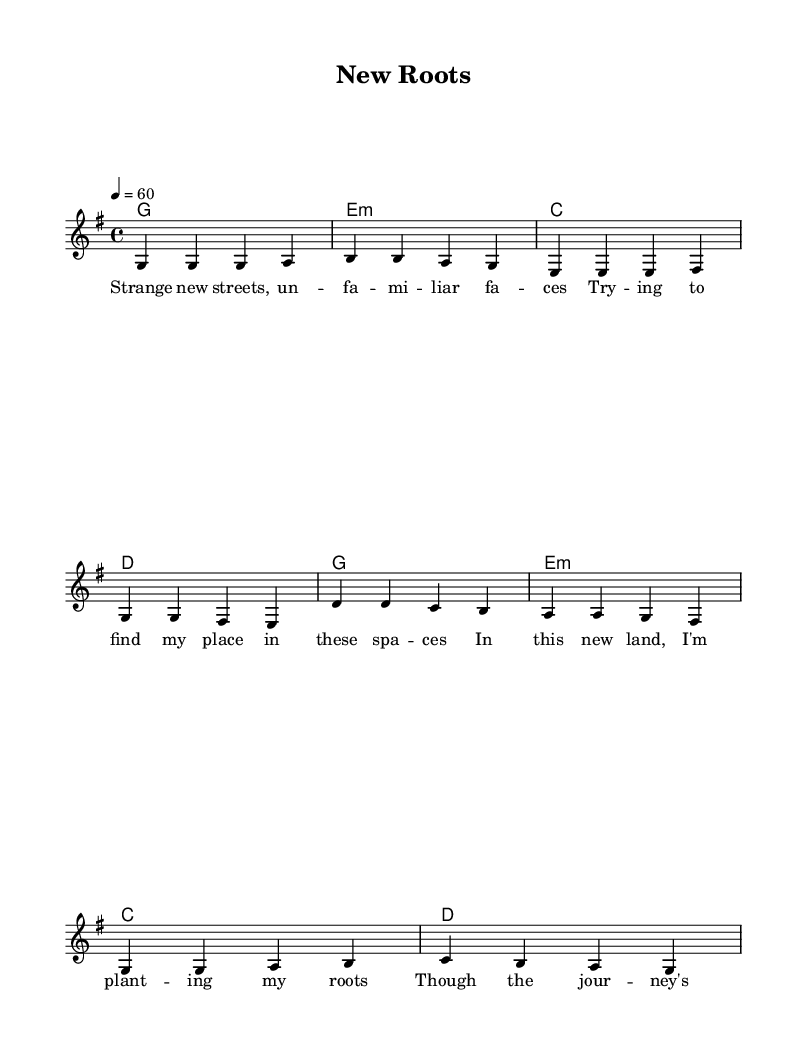What is the key signature of this music? The key signature is G major, which has one sharp (F#). This can be identified at the beginning of the sheet music where the key signature is indicated before the time signature.
Answer: G major What is the time signature of this music? The time signature is 4/4, which means there are four beats in each measure and the quarter note receives one beat. This is shown as a fraction in the beginning section of the sheet music.
Answer: 4/4 What is the tempo marking of this piece? The tempo marking is 60 beats per minute, indicated by the “\tempo 4 = 60” notation on the sheet music. This tells the performer how fast to play the piece.
Answer: 60 How many measures are there in the verse? There are four measures in the verse, which can be counted by looking at the individual measures divided by vertical lines in the melody section of the sheet music.
Answer: 4 What is the structure of the song? The structure is verse-chorus, indicated by the different sections labeled as "Verse" and "Chorus" in the melody part of the sheet music. This is a common format in Rhythm and Blues music, where the repetitive and emotive nature enhances the lyrics.
Answer: Verse-Chorus What type of chord progression is used in the harmonies? The chord progression follows a simple diatonic sequence common in R&B, moving through G major, E minor, C major, and D major repeatedly, which is typical for creating a familiar sound in this genre.
Answer: Diatonic What theme do the lyrics of this song convey? The theme of the lyrics conveys feelings of adaptation and perseverance in a new culture, highlighting the struggles of finding one's place, which aligns with the soulful characteristic of R&B music, focusing on personal experiences and emotions.
Answer: Adaptation 